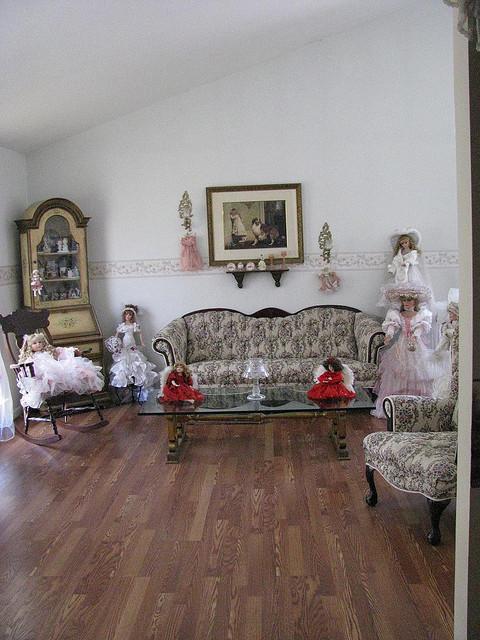Is this room elegant?
Short answer required. Yes. Are there quite a few fancy dolls in the room?
Give a very brief answer. Yes. Is this room tiny?
Quick response, please. No. What are the primary colors in this decor?
Keep it brief. White and brown. 